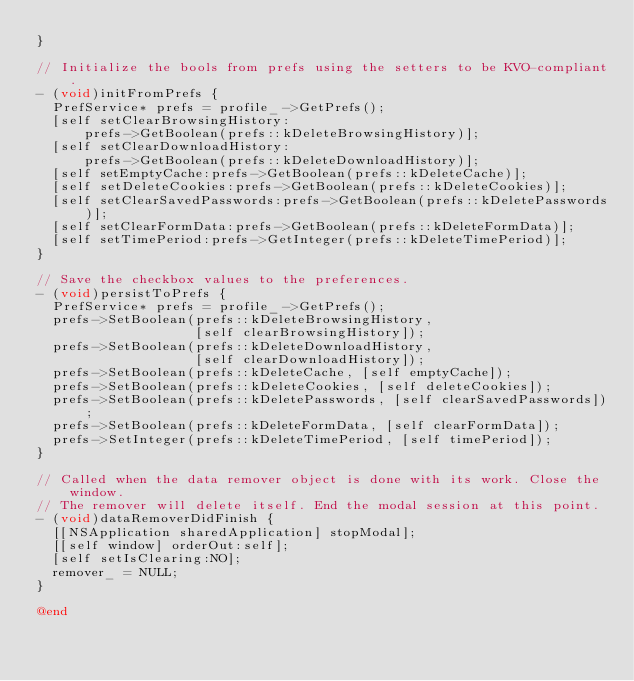<code> <loc_0><loc_0><loc_500><loc_500><_ObjectiveC_>}

// Initialize the bools from prefs using the setters to be KVO-compliant.
- (void)initFromPrefs {
  PrefService* prefs = profile_->GetPrefs();
  [self setClearBrowsingHistory:
      prefs->GetBoolean(prefs::kDeleteBrowsingHistory)];
  [self setClearDownloadHistory:
      prefs->GetBoolean(prefs::kDeleteDownloadHistory)];
  [self setEmptyCache:prefs->GetBoolean(prefs::kDeleteCache)];
  [self setDeleteCookies:prefs->GetBoolean(prefs::kDeleteCookies)];
  [self setClearSavedPasswords:prefs->GetBoolean(prefs::kDeletePasswords)];
  [self setClearFormData:prefs->GetBoolean(prefs::kDeleteFormData)];
  [self setTimePeriod:prefs->GetInteger(prefs::kDeleteTimePeriod)];
}

// Save the checkbox values to the preferences.
- (void)persistToPrefs {
  PrefService* prefs = profile_->GetPrefs();
  prefs->SetBoolean(prefs::kDeleteBrowsingHistory,
                    [self clearBrowsingHistory]);
  prefs->SetBoolean(prefs::kDeleteDownloadHistory,
                    [self clearDownloadHistory]);
  prefs->SetBoolean(prefs::kDeleteCache, [self emptyCache]);
  prefs->SetBoolean(prefs::kDeleteCookies, [self deleteCookies]);
  prefs->SetBoolean(prefs::kDeletePasswords, [self clearSavedPasswords]);
  prefs->SetBoolean(prefs::kDeleteFormData, [self clearFormData]);
  prefs->SetInteger(prefs::kDeleteTimePeriod, [self timePeriod]);
}

// Called when the data remover object is done with its work. Close the window.
// The remover will delete itself. End the modal session at this point.
- (void)dataRemoverDidFinish {
  [[NSApplication sharedApplication] stopModal];
  [[self window] orderOut:self];
  [self setIsClearing:NO];
  remover_ = NULL;
}

@end
</code> 